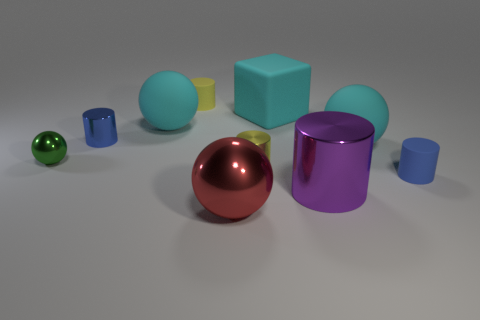Subtract all big purple metallic cylinders. How many cylinders are left? 4 Subtract all red cylinders. Subtract all gray balls. How many cylinders are left? 5 Subtract all balls. How many objects are left? 6 Add 1 large shiny cylinders. How many large shiny cylinders are left? 2 Add 4 tiny blue matte objects. How many tiny blue matte objects exist? 5 Subtract 0 yellow spheres. How many objects are left? 10 Subtract all green metallic objects. Subtract all yellow cylinders. How many objects are left? 7 